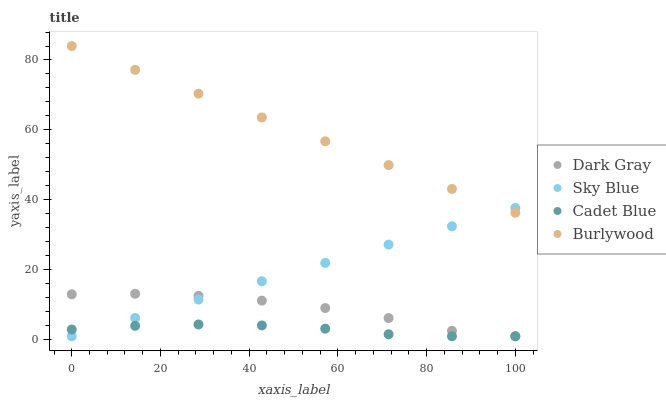Does Cadet Blue have the minimum area under the curve?
Answer yes or no. Yes. Does Burlywood have the maximum area under the curve?
Answer yes or no. Yes. Does Sky Blue have the minimum area under the curve?
Answer yes or no. No. Does Sky Blue have the maximum area under the curve?
Answer yes or no. No. Is Sky Blue the smoothest?
Answer yes or no. Yes. Is Dark Gray the roughest?
Answer yes or no. Yes. Is Cadet Blue the smoothest?
Answer yes or no. No. Is Cadet Blue the roughest?
Answer yes or no. No. Does Dark Gray have the lowest value?
Answer yes or no. Yes. Does Burlywood have the lowest value?
Answer yes or no. No. Does Burlywood have the highest value?
Answer yes or no. Yes. Does Sky Blue have the highest value?
Answer yes or no. No. Is Cadet Blue less than Burlywood?
Answer yes or no. Yes. Is Burlywood greater than Dark Gray?
Answer yes or no. Yes. Does Cadet Blue intersect Dark Gray?
Answer yes or no. Yes. Is Cadet Blue less than Dark Gray?
Answer yes or no. No. Is Cadet Blue greater than Dark Gray?
Answer yes or no. No. Does Cadet Blue intersect Burlywood?
Answer yes or no. No. 